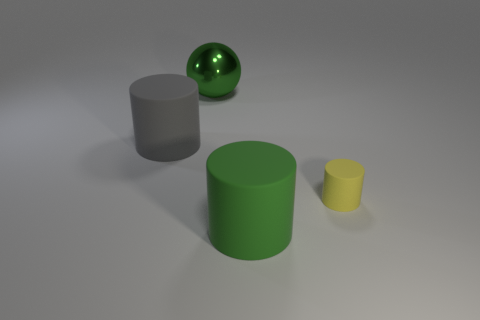Is there anything else that has the same size as the yellow matte cylinder?
Give a very brief answer. No. There is a big matte cylinder that is on the right side of the large green metal ball; is it the same color as the cylinder that is to the right of the green matte cylinder?
Your response must be concise. No. What material is the object that is both behind the small cylinder and in front of the metallic thing?
Your answer should be compact. Rubber. Are there any big green metallic spheres?
Your answer should be compact. Yes. There is a large green matte thing; does it have the same shape as the big green thing that is left of the green rubber thing?
Your answer should be very brief. No. There is a green thing in front of the large cylinder to the left of the large green rubber thing; what is it made of?
Offer a terse response. Rubber. How many other objects are there of the same shape as the small thing?
Ensure brevity in your answer.  2. There is a rubber thing right of the green rubber cylinder; does it have the same shape as the big green object that is to the right of the ball?
Give a very brief answer. Yes. Is there any other thing that is the same material as the gray thing?
Your answer should be very brief. Yes. What material is the big gray cylinder?
Give a very brief answer. Rubber. 